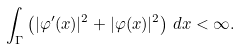Convert formula to latex. <formula><loc_0><loc_0><loc_500><loc_500>\int _ { \Gamma } \left ( | \varphi ^ { \prime } ( x ) | ^ { 2 } + | \varphi ( x ) | ^ { 2 } \right ) \, d x < \infty .</formula> 